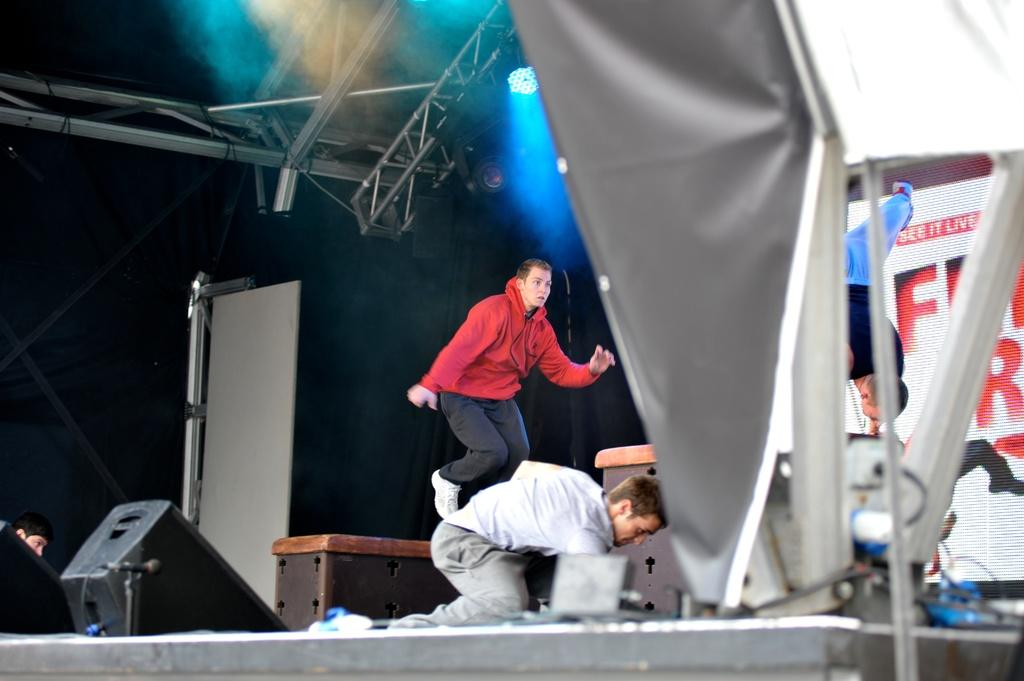What are the people in the image wearing? The people in the image are wearing clothes. What is one person doing in the image? One person is jumping. How is the other person positioned in the image? The other person is upside down. What can be seen on the wall in the image? There is a poster on the wall. What type of illumination is present in the image? There are lights in the image. What object made of wood can be seen in the image? There is a wooden box in the image. What type of slope can be seen in the image? There is no slope present in the image. What is the person writing in the notebook in the image? There is no notebook or person writing in the image. 